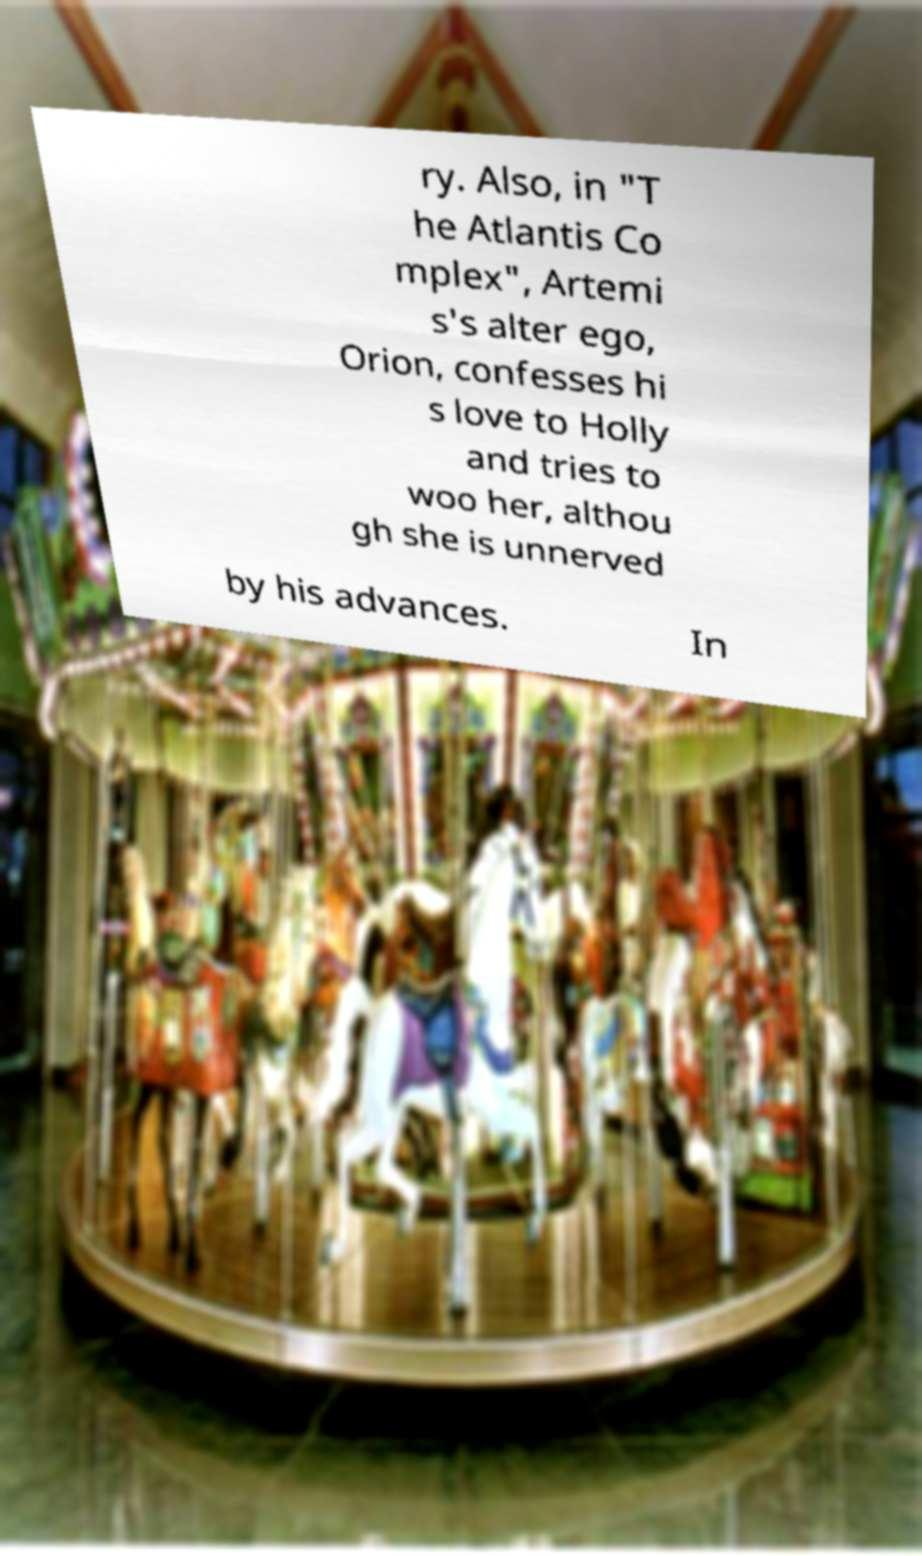I need the written content from this picture converted into text. Can you do that? ry. Also, in "T he Atlantis Co mplex", Artemi s's alter ego, Orion, confesses hi s love to Holly and tries to woo her, althou gh she is unnerved by his advances. In 